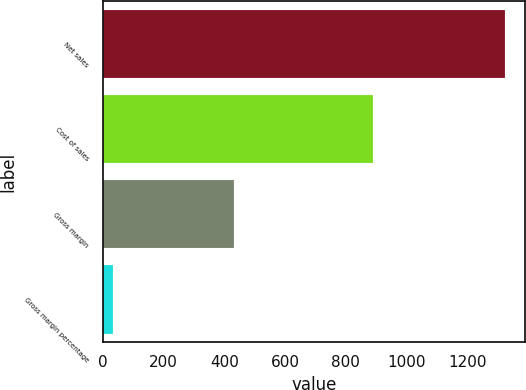Convert chart. <chart><loc_0><loc_0><loc_500><loc_500><bar_chart><fcel>Net sales<fcel>Cost of sales<fcel>Gross margin<fcel>Gross margin percentage<nl><fcel>1322<fcel>889<fcel>433<fcel>32.8<nl></chart> 